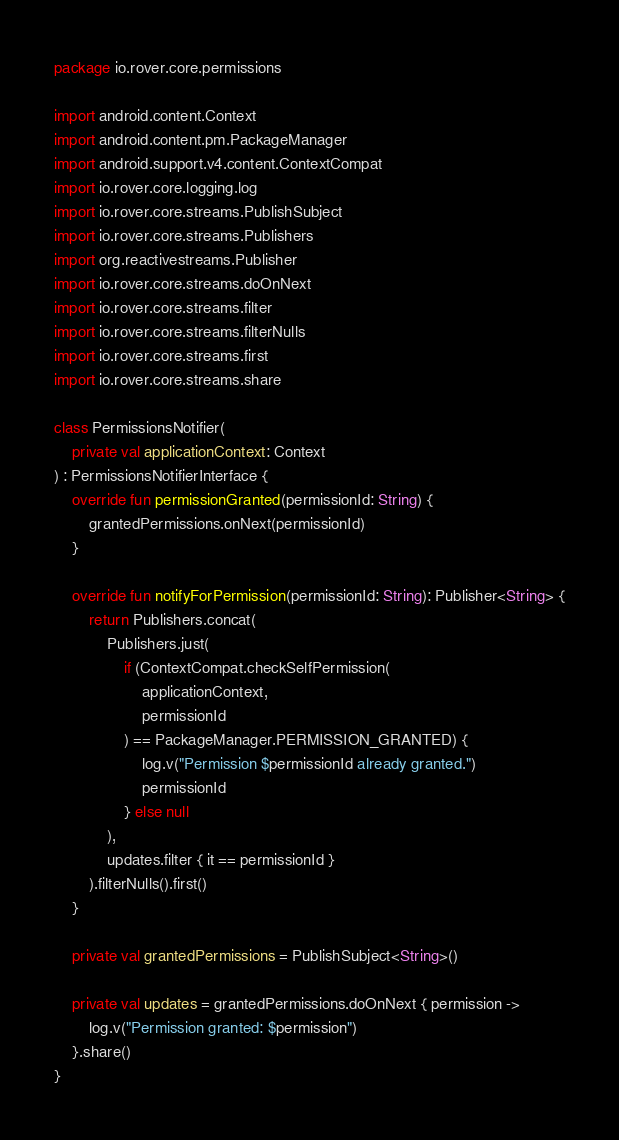<code> <loc_0><loc_0><loc_500><loc_500><_Kotlin_>package io.rover.core.permissions

import android.content.Context
import android.content.pm.PackageManager
import android.support.v4.content.ContextCompat
import io.rover.core.logging.log
import io.rover.core.streams.PublishSubject
import io.rover.core.streams.Publishers
import org.reactivestreams.Publisher
import io.rover.core.streams.doOnNext
import io.rover.core.streams.filter
import io.rover.core.streams.filterNulls
import io.rover.core.streams.first
import io.rover.core.streams.share

class PermissionsNotifier(
    private val applicationContext: Context
) : PermissionsNotifierInterface {
    override fun permissionGranted(permissionId: String) {
        grantedPermissions.onNext(permissionId)
    }

    override fun notifyForPermission(permissionId: String): Publisher<String> {
        return Publishers.concat(
            Publishers.just(
                if (ContextCompat.checkSelfPermission(
                    applicationContext,
                    permissionId
                ) == PackageManager.PERMISSION_GRANTED) {
                    log.v("Permission $permissionId already granted.")
                    permissionId
                } else null
            ),
            updates.filter { it == permissionId }
        ).filterNulls().first()
    }

    private val grantedPermissions = PublishSubject<String>()

    private val updates = grantedPermissions.doOnNext { permission ->
        log.v("Permission granted: $permission")
    }.share()
}
</code> 